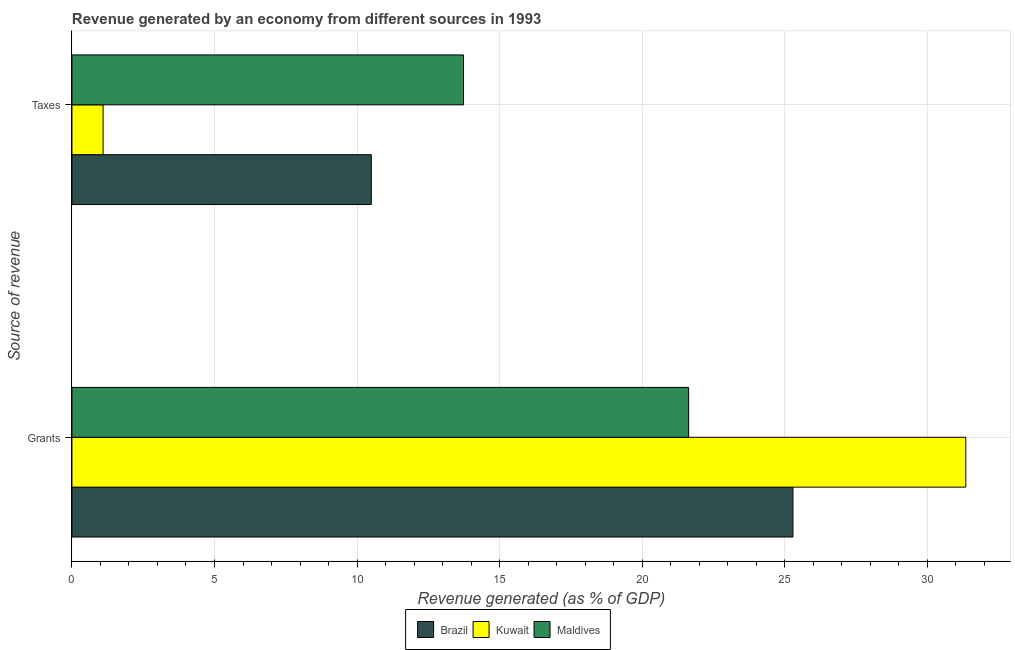How many different coloured bars are there?
Ensure brevity in your answer.  3. Are the number of bars per tick equal to the number of legend labels?
Keep it short and to the point. Yes. How many bars are there on the 2nd tick from the top?
Give a very brief answer. 3. How many bars are there on the 1st tick from the bottom?
Provide a short and direct response. 3. What is the label of the 2nd group of bars from the top?
Your answer should be very brief. Grants. What is the revenue generated by grants in Brazil?
Offer a very short reply. 25.29. Across all countries, what is the maximum revenue generated by taxes?
Your answer should be compact. 13.73. Across all countries, what is the minimum revenue generated by taxes?
Provide a succinct answer. 1.09. In which country was the revenue generated by grants maximum?
Keep it short and to the point. Kuwait. In which country was the revenue generated by taxes minimum?
Ensure brevity in your answer.  Kuwait. What is the total revenue generated by taxes in the graph?
Offer a very short reply. 25.33. What is the difference between the revenue generated by grants in Kuwait and that in Maldives?
Provide a succinct answer. 9.72. What is the difference between the revenue generated by grants in Kuwait and the revenue generated by taxes in Maldives?
Your answer should be compact. 17.62. What is the average revenue generated by grants per country?
Make the answer very short. 26.09. What is the difference between the revenue generated by taxes and revenue generated by grants in Maldives?
Offer a very short reply. -7.9. In how many countries, is the revenue generated by grants greater than 22 %?
Your answer should be very brief. 2. What is the ratio of the revenue generated by taxes in Maldives to that in Kuwait?
Give a very brief answer. 12.57. Is the revenue generated by taxes in Brazil less than that in Maldives?
Provide a short and direct response. Yes. What does the 3rd bar from the top in Grants represents?
Your answer should be compact. Brazil. What does the 1st bar from the bottom in Grants represents?
Your response must be concise. Brazil. How many bars are there?
Your response must be concise. 6. Are all the bars in the graph horizontal?
Ensure brevity in your answer.  Yes. What is the difference between two consecutive major ticks on the X-axis?
Provide a short and direct response. 5. Are the values on the major ticks of X-axis written in scientific E-notation?
Offer a terse response. No. Where does the legend appear in the graph?
Your answer should be very brief. Bottom center. How many legend labels are there?
Ensure brevity in your answer.  3. How are the legend labels stacked?
Keep it short and to the point. Horizontal. What is the title of the graph?
Keep it short and to the point. Revenue generated by an economy from different sources in 1993. What is the label or title of the X-axis?
Your response must be concise. Revenue generated (as % of GDP). What is the label or title of the Y-axis?
Ensure brevity in your answer.  Source of revenue. What is the Revenue generated (as % of GDP) in Brazil in Grants?
Give a very brief answer. 25.29. What is the Revenue generated (as % of GDP) in Kuwait in Grants?
Ensure brevity in your answer.  31.35. What is the Revenue generated (as % of GDP) in Maldives in Grants?
Ensure brevity in your answer.  21.63. What is the Revenue generated (as % of GDP) in Brazil in Taxes?
Provide a succinct answer. 10.5. What is the Revenue generated (as % of GDP) of Kuwait in Taxes?
Your response must be concise. 1.09. What is the Revenue generated (as % of GDP) of Maldives in Taxes?
Give a very brief answer. 13.73. Across all Source of revenue, what is the maximum Revenue generated (as % of GDP) of Brazil?
Offer a very short reply. 25.29. Across all Source of revenue, what is the maximum Revenue generated (as % of GDP) in Kuwait?
Make the answer very short. 31.35. Across all Source of revenue, what is the maximum Revenue generated (as % of GDP) of Maldives?
Your answer should be compact. 21.63. Across all Source of revenue, what is the minimum Revenue generated (as % of GDP) in Brazil?
Keep it short and to the point. 10.5. Across all Source of revenue, what is the minimum Revenue generated (as % of GDP) of Kuwait?
Give a very brief answer. 1.09. Across all Source of revenue, what is the minimum Revenue generated (as % of GDP) in Maldives?
Your answer should be very brief. 13.73. What is the total Revenue generated (as % of GDP) of Brazil in the graph?
Offer a terse response. 35.79. What is the total Revenue generated (as % of GDP) in Kuwait in the graph?
Make the answer very short. 32.45. What is the total Revenue generated (as % of GDP) of Maldives in the graph?
Provide a short and direct response. 35.37. What is the difference between the Revenue generated (as % of GDP) of Brazil in Grants and that in Taxes?
Provide a succinct answer. 14.79. What is the difference between the Revenue generated (as % of GDP) in Kuwait in Grants and that in Taxes?
Offer a terse response. 30.26. What is the difference between the Revenue generated (as % of GDP) of Maldives in Grants and that in Taxes?
Your answer should be very brief. 7.9. What is the difference between the Revenue generated (as % of GDP) of Brazil in Grants and the Revenue generated (as % of GDP) of Kuwait in Taxes?
Provide a succinct answer. 24.2. What is the difference between the Revenue generated (as % of GDP) in Brazil in Grants and the Revenue generated (as % of GDP) in Maldives in Taxes?
Your response must be concise. 11.56. What is the difference between the Revenue generated (as % of GDP) of Kuwait in Grants and the Revenue generated (as % of GDP) of Maldives in Taxes?
Give a very brief answer. 17.62. What is the average Revenue generated (as % of GDP) in Brazil per Source of revenue?
Give a very brief answer. 17.9. What is the average Revenue generated (as % of GDP) of Kuwait per Source of revenue?
Your answer should be very brief. 16.22. What is the average Revenue generated (as % of GDP) in Maldives per Source of revenue?
Offer a very short reply. 17.68. What is the difference between the Revenue generated (as % of GDP) of Brazil and Revenue generated (as % of GDP) of Kuwait in Grants?
Your answer should be compact. -6.06. What is the difference between the Revenue generated (as % of GDP) in Brazil and Revenue generated (as % of GDP) in Maldives in Grants?
Your answer should be compact. 3.66. What is the difference between the Revenue generated (as % of GDP) of Kuwait and Revenue generated (as % of GDP) of Maldives in Grants?
Provide a succinct answer. 9.72. What is the difference between the Revenue generated (as % of GDP) of Brazil and Revenue generated (as % of GDP) of Kuwait in Taxes?
Provide a succinct answer. 9.41. What is the difference between the Revenue generated (as % of GDP) of Brazil and Revenue generated (as % of GDP) of Maldives in Taxes?
Your answer should be very brief. -3.23. What is the difference between the Revenue generated (as % of GDP) of Kuwait and Revenue generated (as % of GDP) of Maldives in Taxes?
Your answer should be compact. -12.64. What is the ratio of the Revenue generated (as % of GDP) of Brazil in Grants to that in Taxes?
Offer a terse response. 2.41. What is the ratio of the Revenue generated (as % of GDP) of Kuwait in Grants to that in Taxes?
Provide a succinct answer. 28.7. What is the ratio of the Revenue generated (as % of GDP) in Maldives in Grants to that in Taxes?
Your answer should be very brief. 1.57. What is the difference between the highest and the second highest Revenue generated (as % of GDP) in Brazil?
Make the answer very short. 14.79. What is the difference between the highest and the second highest Revenue generated (as % of GDP) in Kuwait?
Offer a terse response. 30.26. What is the difference between the highest and the second highest Revenue generated (as % of GDP) in Maldives?
Your answer should be very brief. 7.9. What is the difference between the highest and the lowest Revenue generated (as % of GDP) in Brazil?
Provide a succinct answer. 14.79. What is the difference between the highest and the lowest Revenue generated (as % of GDP) in Kuwait?
Provide a short and direct response. 30.26. What is the difference between the highest and the lowest Revenue generated (as % of GDP) of Maldives?
Make the answer very short. 7.9. 